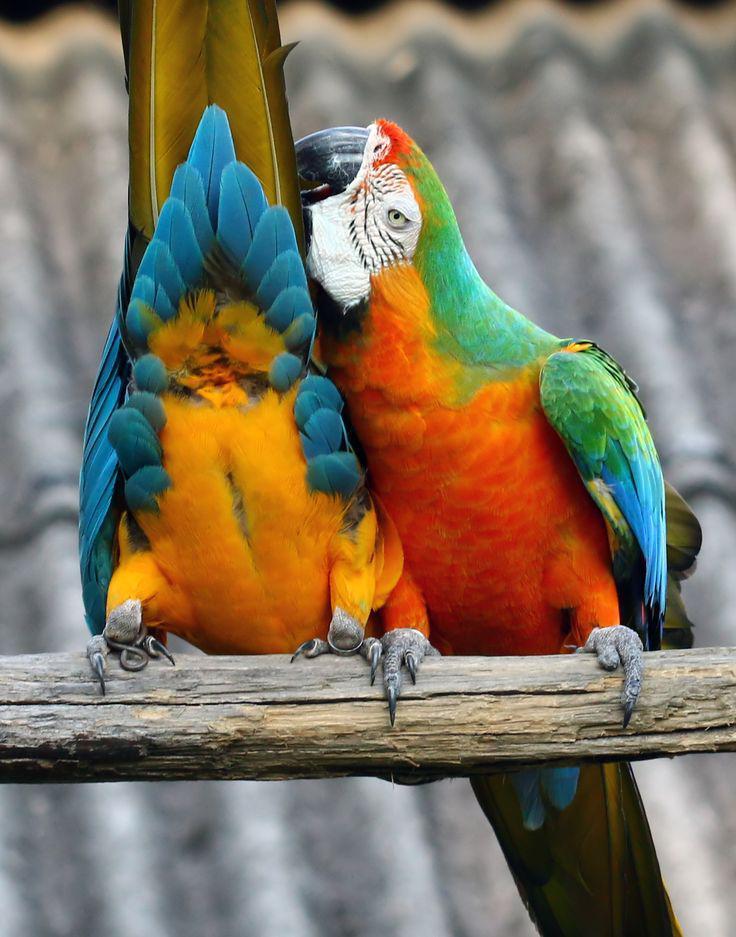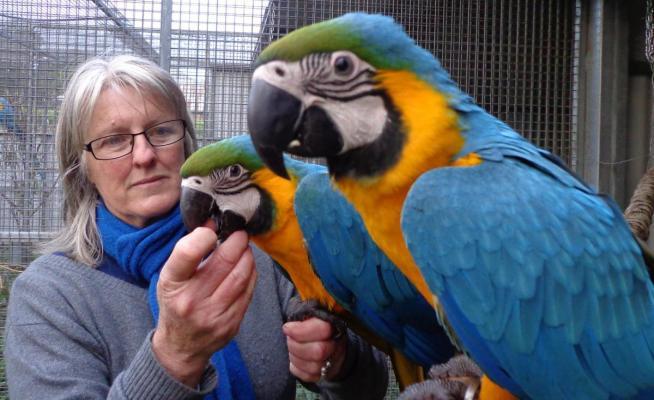The first image is the image on the left, the second image is the image on the right. For the images displayed, is the sentence "There are exactly four birds in total." factually correct? Answer yes or no. Yes. The first image is the image on the left, the second image is the image on the right. Examine the images to the left and right. Is the description "There are no less than three parrots resting on a branch." accurate? Answer yes or no. No. 